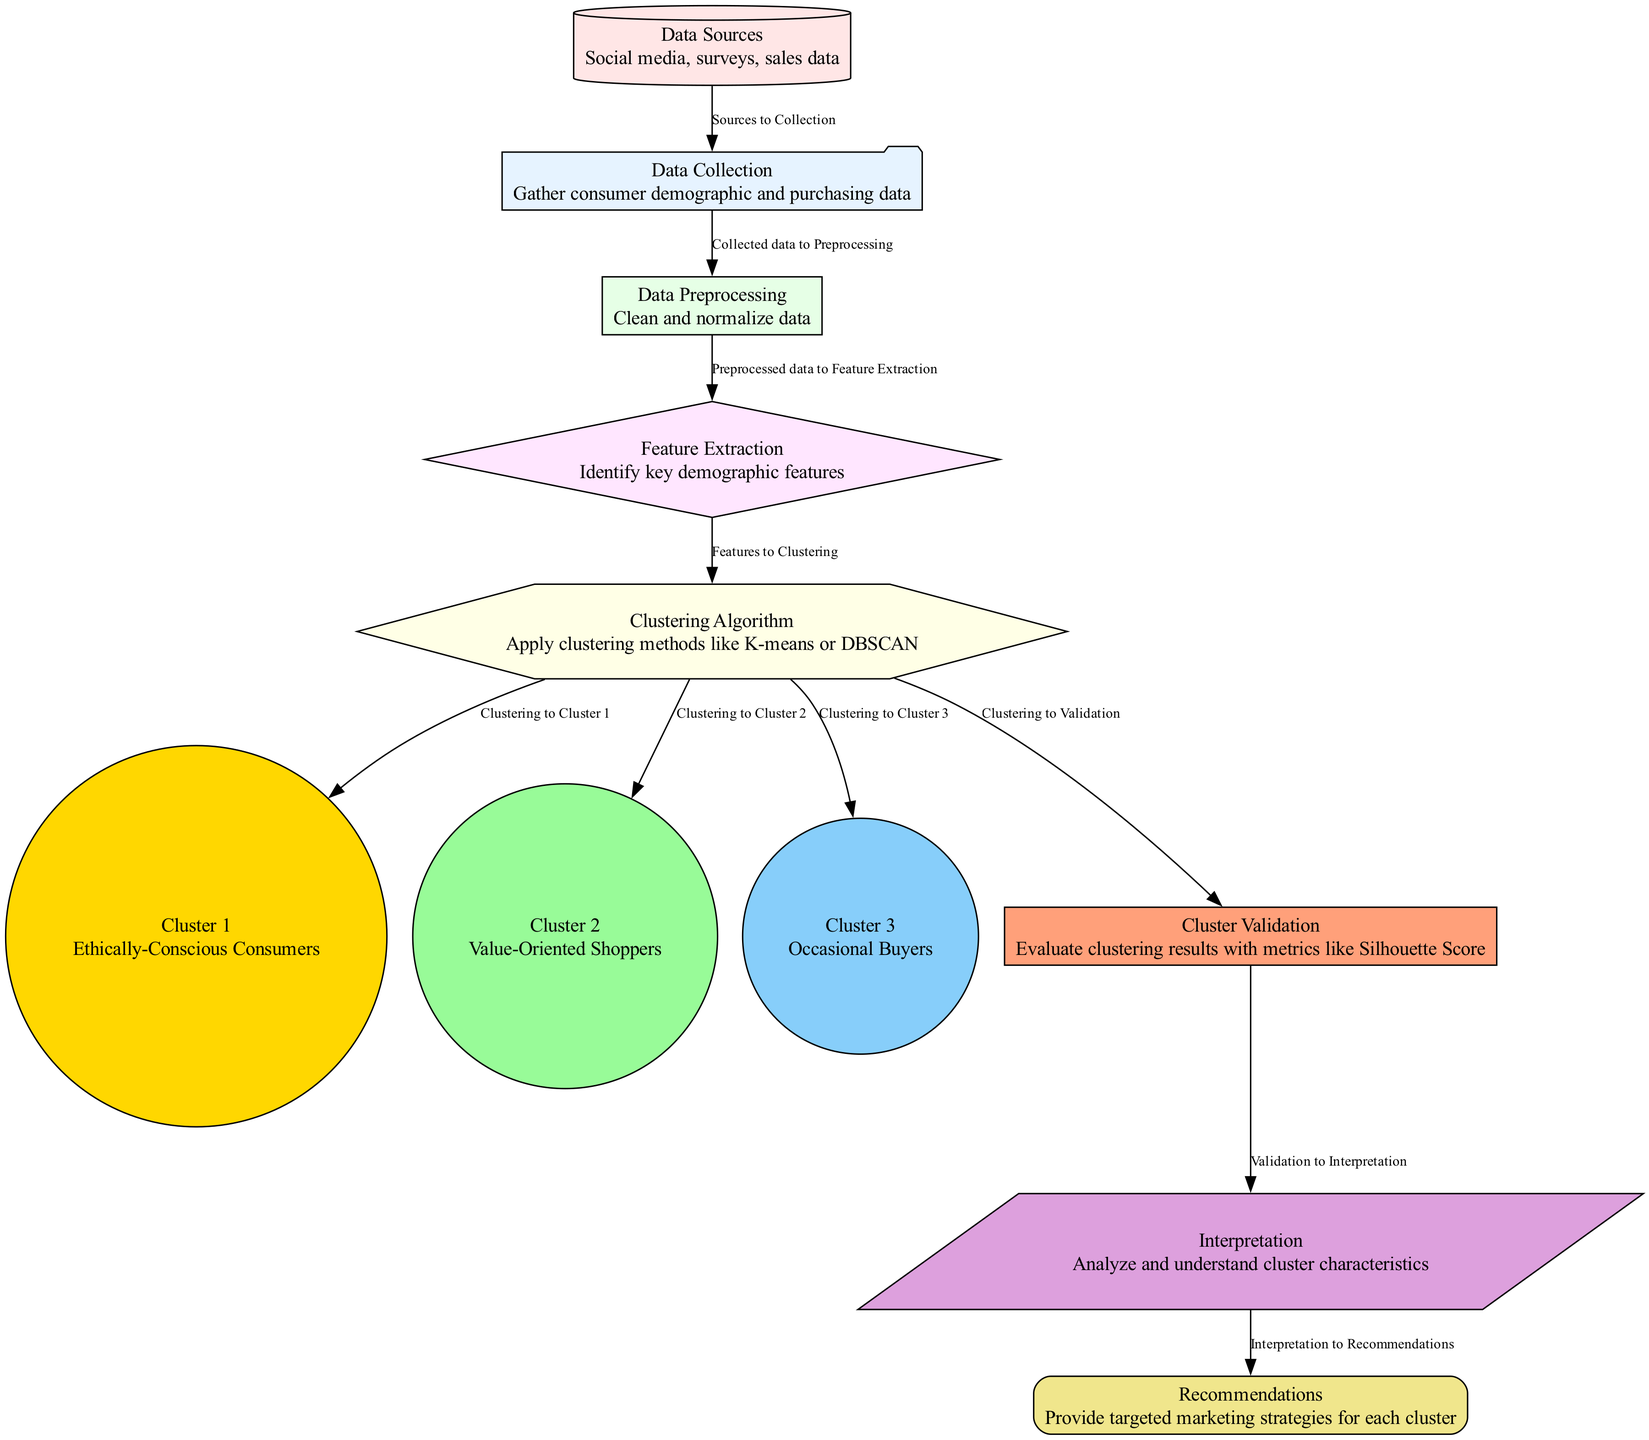What is the first step in the diagram? The first step in the diagram is 'Data Collection', which involves gathering consumer demographic and purchasing data. This is represented at the start of the flow as the initial node before any processing occurs.
Answer: Data Collection How many clusters are determined in the clustering analysis? The diagram outlines three distinct clusters resulting from the clustering analysis: Cluster 1, Cluster 2, and Cluster 3. This is identified from the branching off after the clustering algorithm node.
Answer: Three Which algorithm is used for clustering in this analysis? The clustering methods indicated in the diagram include K-means or DBSCAN, which are specified in the 'Clustering Algorithm' node. The algorithm serves as a key for grouping consumers based on their demographic information.
Answer: Clustering Algorithm What role does 'Cluster Validation' play in the diagram? 'Cluster Validation' is essential as it evaluates the clustering results using metrics like the Silhouette Score. It shows the importance of confirming the quality of clusters before proceeding to interpretation and recommendations.
Answer: Evaluate clustering results Which cluster represents ethically-conscious consumers? Cluster 1 is detailed in the diagram as representing 'Ethically-Conscious Consumers', explicitly highlighting the target demographic associated with ethical fashion initiatives.
Answer: Cluster 1 What is the relationship between 'Interpretation' and 'Recommendations'? 'Interpretation' directly leads to 'Recommendations', indicating that the analysis of cluster characteristics helps shape targeted marketing strategies for each consumer segment. This shows how insights are transformed into actionable strategies.
Answer: Interpretation to Recommendations What is included in the 'Data Sources' category? The 'Data Sources' category encompasses social media, surveys, and sales data as various channels for gathering information about consumer demographics. This is clearly marked in the initial part of the diagram.
Answer: Social media, surveys, sales data What is the purpose of 'Feature Extraction'? 'Feature Extraction' is utilized to identify key demographic features from the preprocessed data, forming the attributes necessary for effective clustering. This step is crucial for the success of the subsequent clustering algorithm.
Answer: Identify key demographic features 